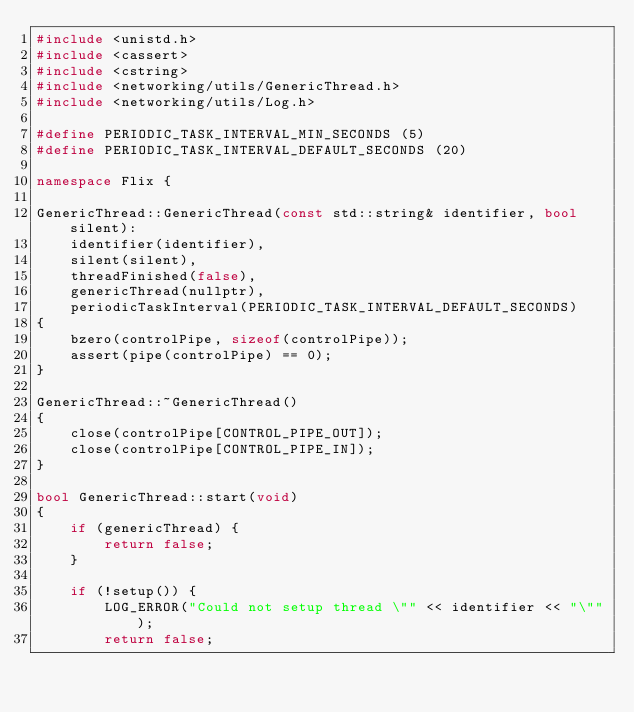Convert code to text. <code><loc_0><loc_0><loc_500><loc_500><_C++_>#include <unistd.h>
#include <cassert>
#include <cstring>
#include <networking/utils/GenericThread.h>
#include <networking/utils/Log.h>

#define PERIODIC_TASK_INTERVAL_MIN_SECONDS (5)
#define PERIODIC_TASK_INTERVAL_DEFAULT_SECONDS (20)

namespace Flix {

GenericThread::GenericThread(const std::string& identifier, bool silent):
    identifier(identifier),
    silent(silent),
    threadFinished(false),
    genericThread(nullptr),
    periodicTaskInterval(PERIODIC_TASK_INTERVAL_DEFAULT_SECONDS)
{
    bzero(controlPipe, sizeof(controlPipe));
    assert(pipe(controlPipe) == 0);
}

GenericThread::~GenericThread()
{
    close(controlPipe[CONTROL_PIPE_OUT]);
    close(controlPipe[CONTROL_PIPE_IN]);
}

bool GenericThread::start(void)
{
    if (genericThread) {
        return false;
    }

    if (!setup()) {
        LOG_ERROR("Could not setup thread \"" << identifier << "\"");
        return false;</code> 